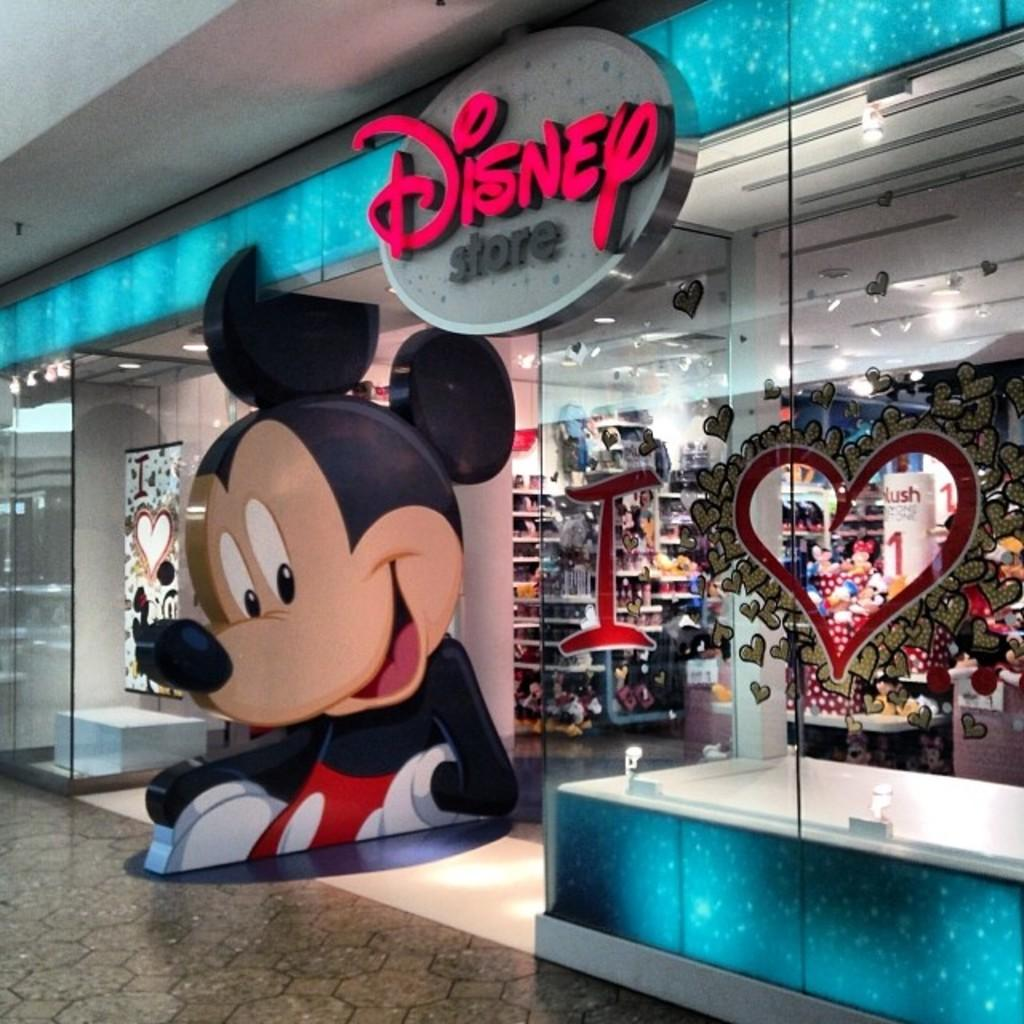What character is present in the image? There is a Mickey Mouse in the image. What material is visible in the image? There is glass in the image. Can you describe the objects in the image? There are some objects in the image, but their specific details are not mentioned in the provided facts. What date is marked on the calendar in the image? There is no calendar present in the image, so it is not possible to answer that question. 